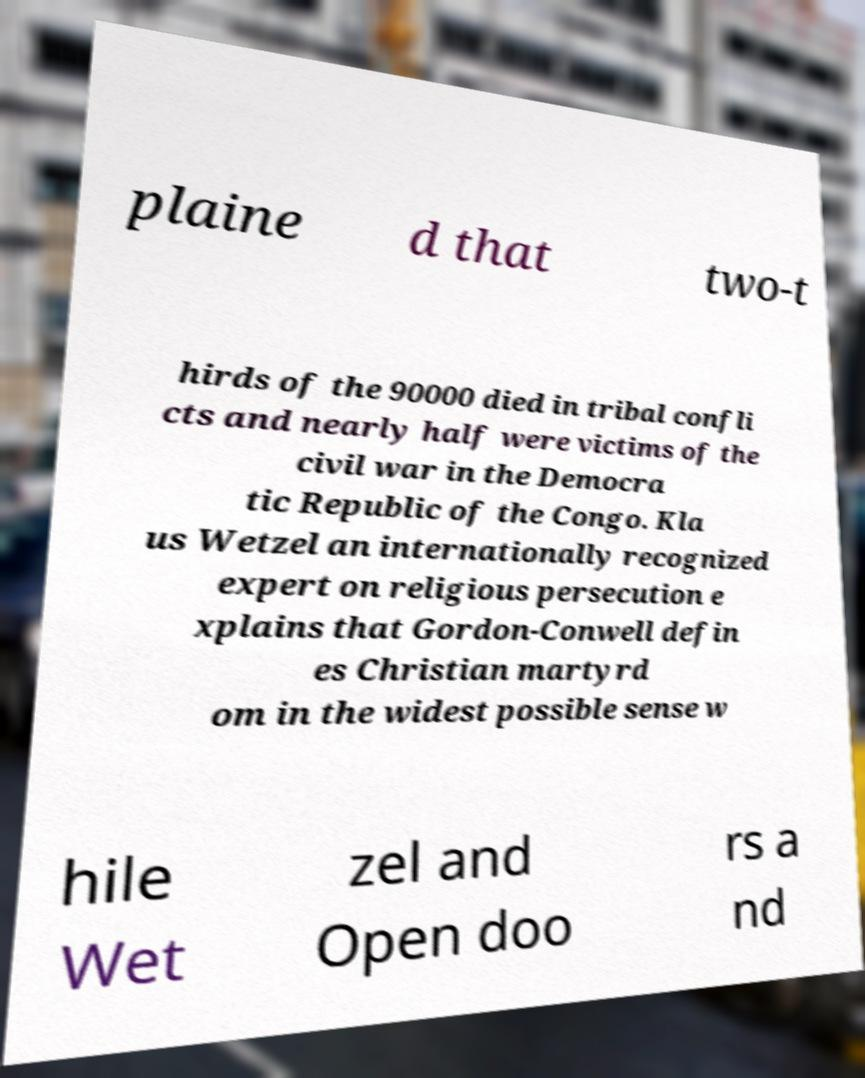Please read and relay the text visible in this image. What does it say? plaine d that two-t hirds of the 90000 died in tribal confli cts and nearly half were victims of the civil war in the Democra tic Republic of the Congo. Kla us Wetzel an internationally recognized expert on religious persecution e xplains that Gordon-Conwell defin es Christian martyrd om in the widest possible sense w hile Wet zel and Open doo rs a nd 